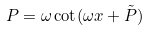<formula> <loc_0><loc_0><loc_500><loc_500>P = \omega \cot ( \omega x + \tilde { P } )</formula> 